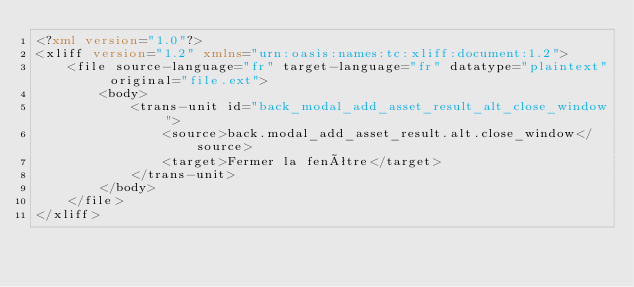Convert code to text. <code><loc_0><loc_0><loc_500><loc_500><_XML_><?xml version="1.0"?>
<xliff version="1.2" xmlns="urn:oasis:names:tc:xliff:document:1.2">
    <file source-language="fr" target-language="fr" datatype="plaintext" original="file.ext">
        <body>
            <trans-unit id="back_modal_add_asset_result_alt_close_window">
                <source>back.modal_add_asset_result.alt.close_window</source>
                <target>Fermer la fenêtre</target>
            </trans-unit>
        </body>
    </file>
</xliff>
</code> 